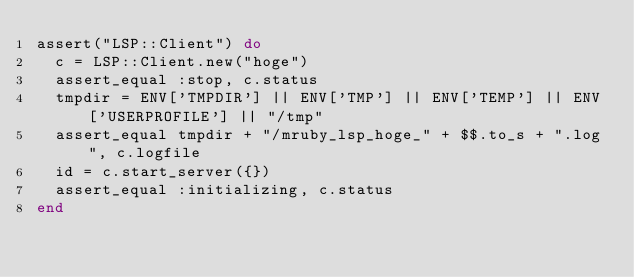<code> <loc_0><loc_0><loc_500><loc_500><_Ruby_>assert("LSP::Client") do
  c = LSP::Client.new("hoge")
  assert_equal :stop, c.status
  tmpdir = ENV['TMPDIR'] || ENV['TMP'] || ENV['TEMP'] || ENV['USERPROFILE'] || "/tmp"
  assert_equal tmpdir + "/mruby_lsp_hoge_" + $$.to_s + ".log", c.logfile
  id = c.start_server({})
  assert_equal :initializing, c.status
end
</code> 